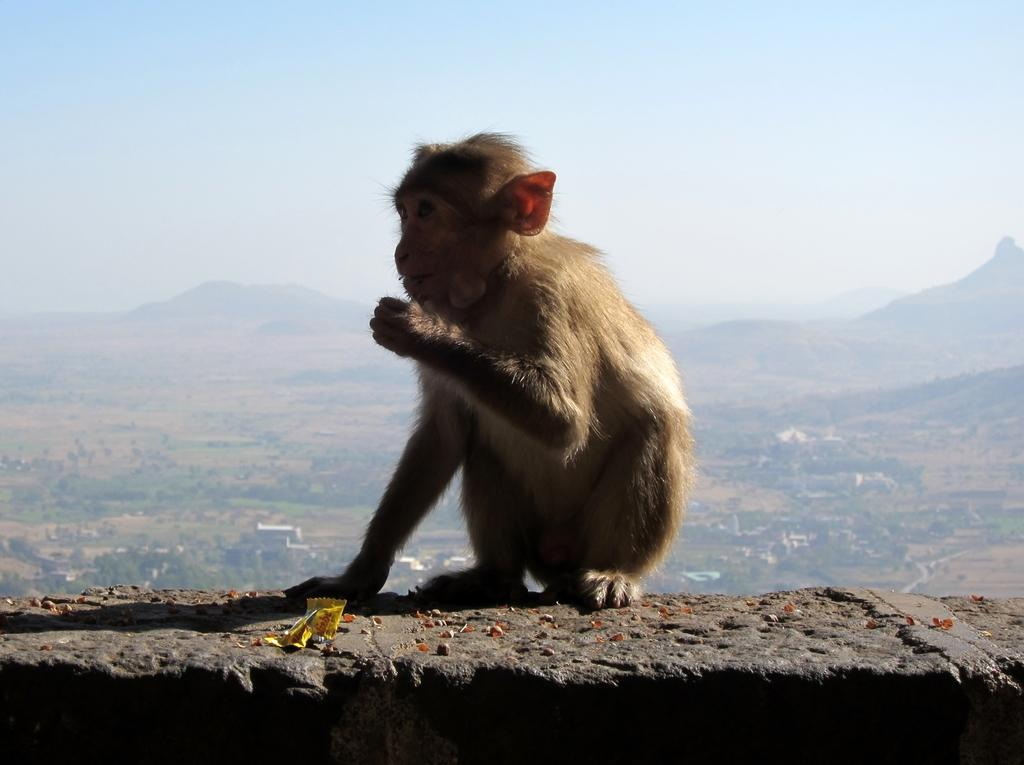What animal is present in the image? There is a monkey in the image. Where is the monkey located? The monkey is sitting on a wall. What is the monkey doing in the image? The monkey is eating grains. What can be seen in the background of the image? Hills, plants, and trees are visible in the background of the image. What part of the natural environment is visible in the image? The sky is visible in the image. What type of beam is the monkey using to win the battle in the image? There is no beam or battle present in the image; it features a monkey sitting on a wall and eating grains. Where did the monkey go on vacation in the image? There is no indication of a vacation in the image; it simply shows a monkey sitting on a wall and eating grains. 